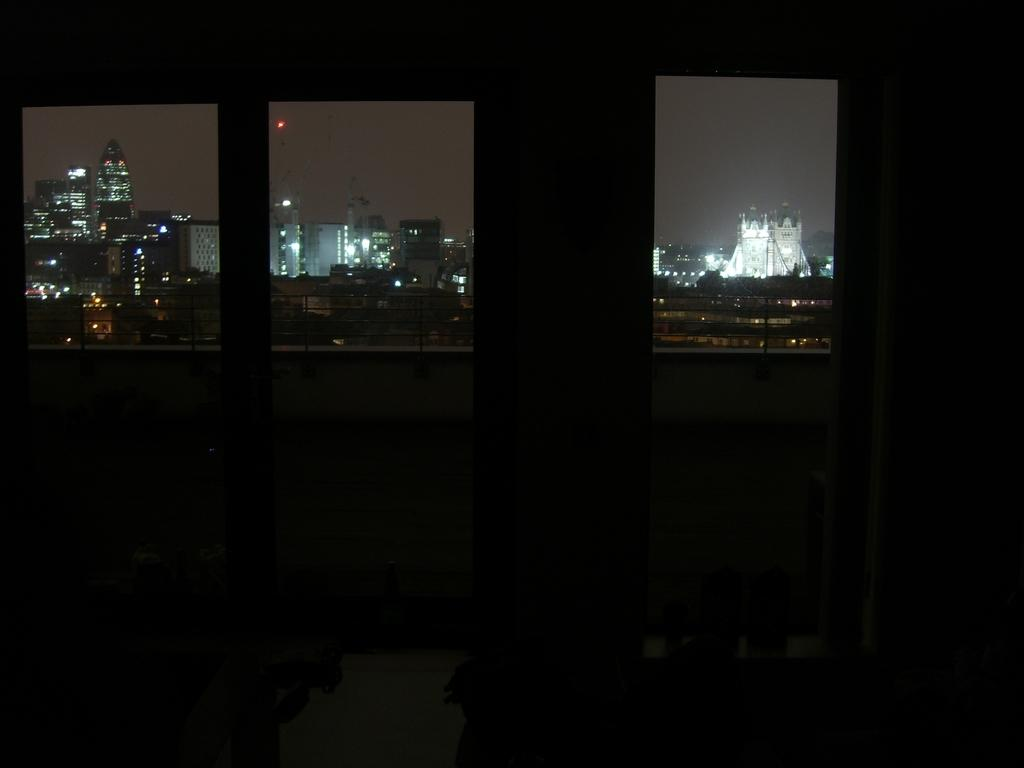How many glass windows are visible in the image? There are three glass windows in the image. What can be seen through the windows? Buildings are visible behind the windows. What feature of the buildings can be observed? The buildings have lights. Can you see any grapes growing on the buildings in the image? There are no grapes visible in the image; the focus is on the glass windows and the buildings behind them. 